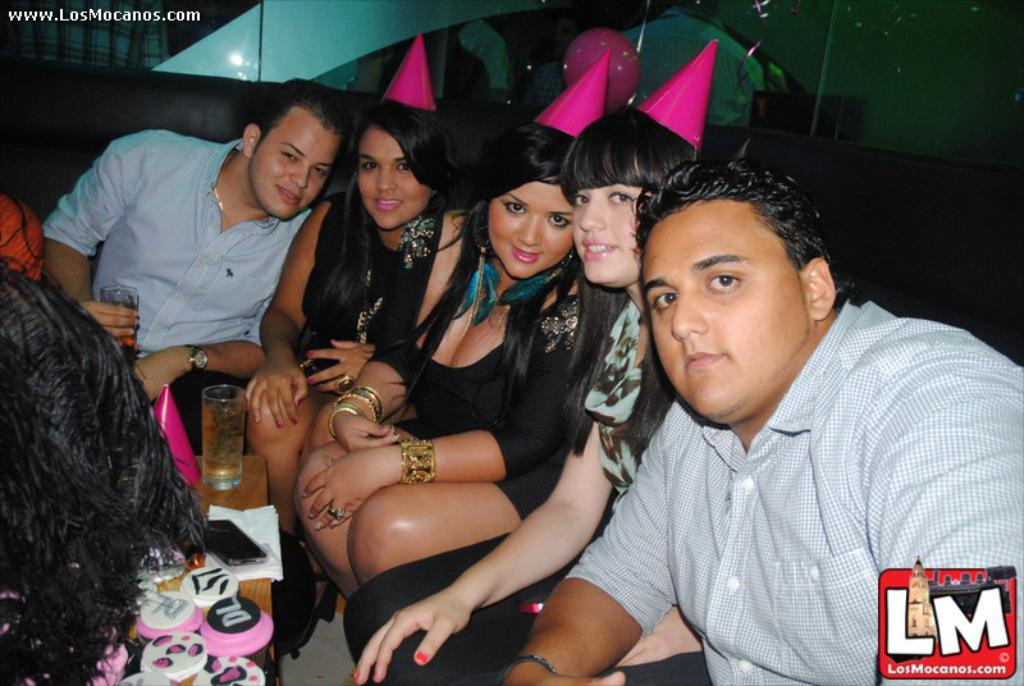What are the people in the image doing? The people in the image are sitting. What is present in the image that the people might be sitting around? There is a table in the image. What can be seen on the table? There are objects on the table. What is visible at the bottom of the image? There is glass visible at the bottom of the image. What type of berry is being read by the visitor in the image? There is no berry or visitor present in the image, and no one is reading. 